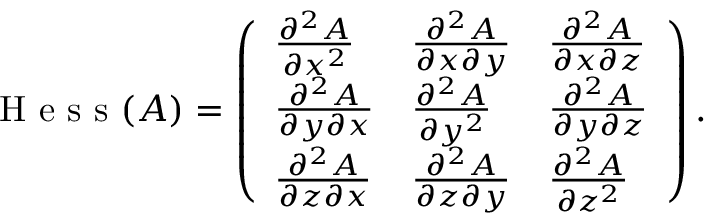<formula> <loc_0><loc_0><loc_500><loc_500>H e s s ( A ) = \left ( \begin{array} { l l l } { \frac { \partial ^ { 2 } A } { \partial x ^ { 2 } } } & { \frac { \partial ^ { 2 } A } { \partial x \partial y } } & { \frac { \partial ^ { 2 } A } { \partial x \partial z } } \\ { \frac { \partial ^ { 2 } A } { \partial y \partial x } } & { \frac { \partial ^ { 2 } A } { \partial y ^ { 2 } } } & { \frac { \partial ^ { 2 } A } { \partial y \partial z } } \\ { \frac { \partial ^ { 2 } A } { \partial z \partial x } } & { \frac { \partial ^ { 2 } A } { \partial z \partial y } } & { \frac { \partial ^ { 2 } A } { \partial z ^ { 2 } } } \end{array} \right ) .</formula> 